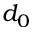Convert formula to latex. <formula><loc_0><loc_0><loc_500><loc_500>d _ { 0 }</formula> 